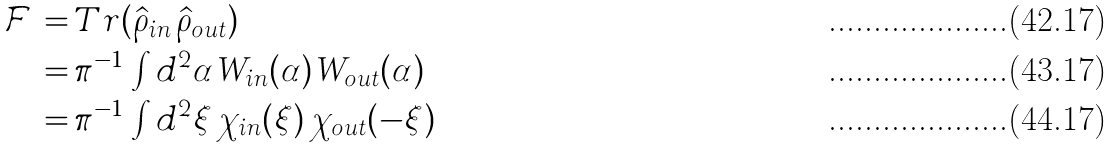<formula> <loc_0><loc_0><loc_500><loc_500>\mathcal { F } \, = & \, T r ( \hat { \rho } _ { i n } \, \hat { \rho } _ { o u t } ) \\ = & \, \pi ^ { - 1 } \, \int d ^ { 2 } \alpha \, W _ { i n } ( \alpha ) \, W _ { o u t } ( \alpha ) \\ = & \, \pi ^ { - 1 } \, \int d ^ { 2 } \xi \, \chi _ { i n } ( \xi ) \, \chi _ { o u t } ( - \xi )</formula> 